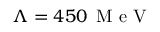<formula> <loc_0><loc_0><loc_500><loc_500>\Lambda = 4 5 0 \, M e V</formula> 